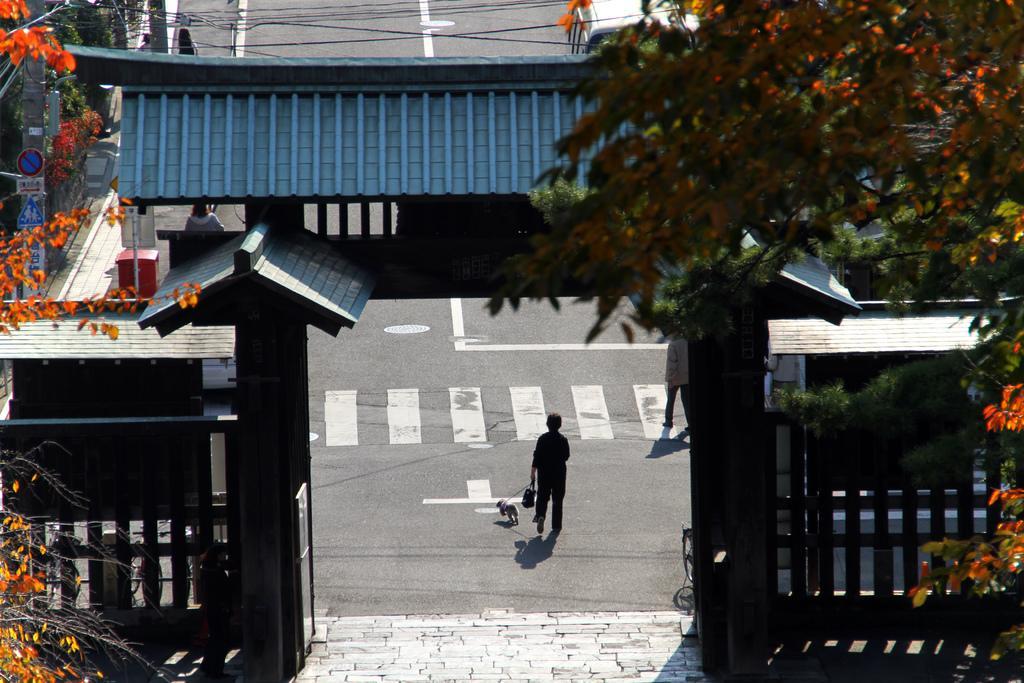Can you describe this image briefly? In this image we can see some people walking on the road. In that a woman is holding a bag and a dog. We can also see an arch, the signboards, a pole, trees and some wires. 